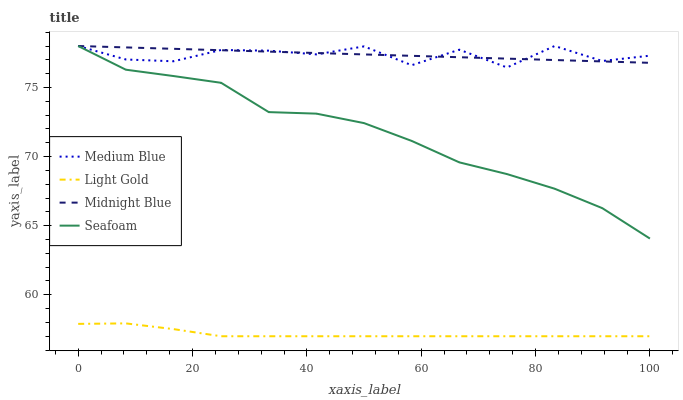Does Medium Blue have the minimum area under the curve?
Answer yes or no. No. Does Medium Blue have the maximum area under the curve?
Answer yes or no. No. Is Medium Blue the smoothest?
Answer yes or no. No. Is Midnight Blue the roughest?
Answer yes or no. No. Does Medium Blue have the lowest value?
Answer yes or no. No. Is Light Gold less than Medium Blue?
Answer yes or no. Yes. Is Midnight Blue greater than Light Gold?
Answer yes or no. Yes. Does Light Gold intersect Medium Blue?
Answer yes or no. No. 